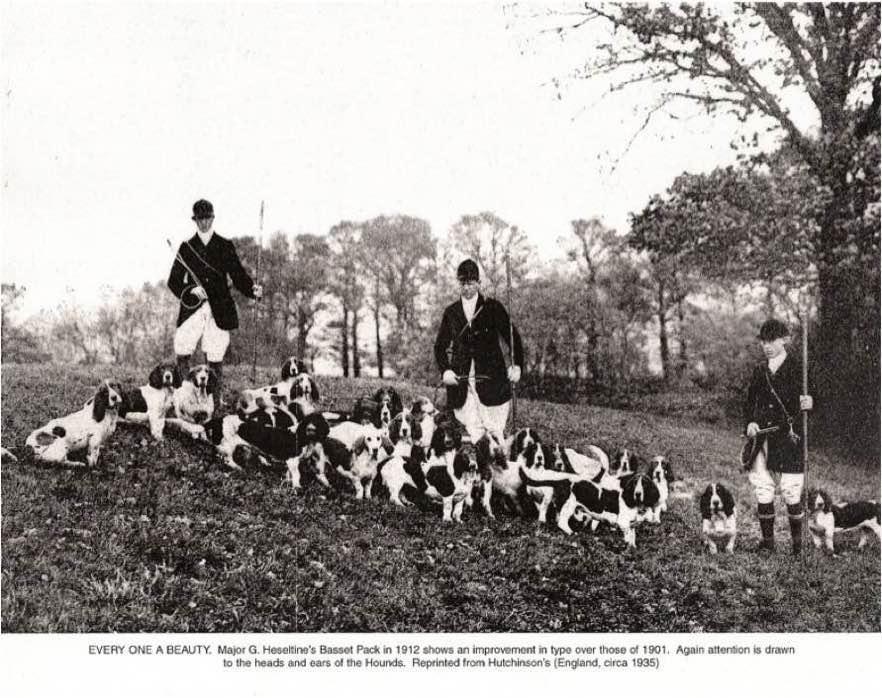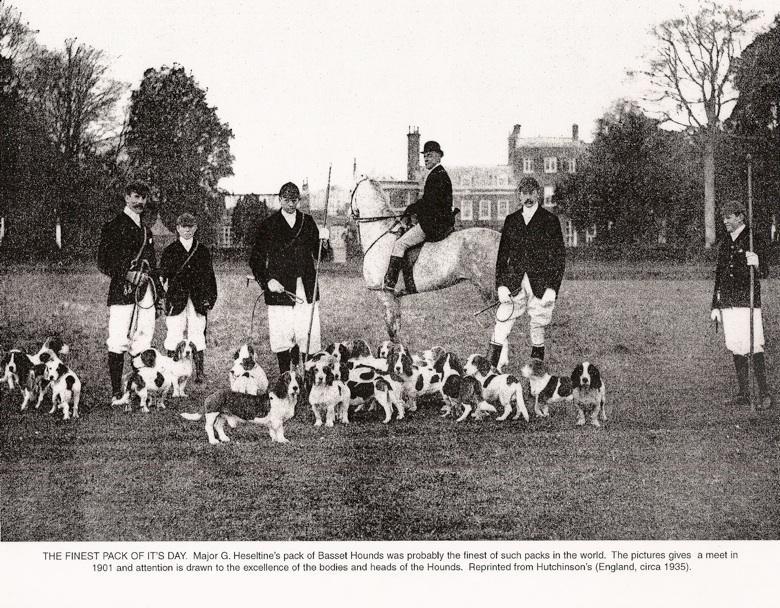The first image is the image on the left, the second image is the image on the right. Analyze the images presented: Is the assertion "There are at most one human near dogs in the image pair." valid? Answer yes or no. No. The first image is the image on the left, the second image is the image on the right. For the images displayed, is the sentence "Both images show at least one person standing behind a pack of hound dogs." factually correct? Answer yes or no. Yes. 